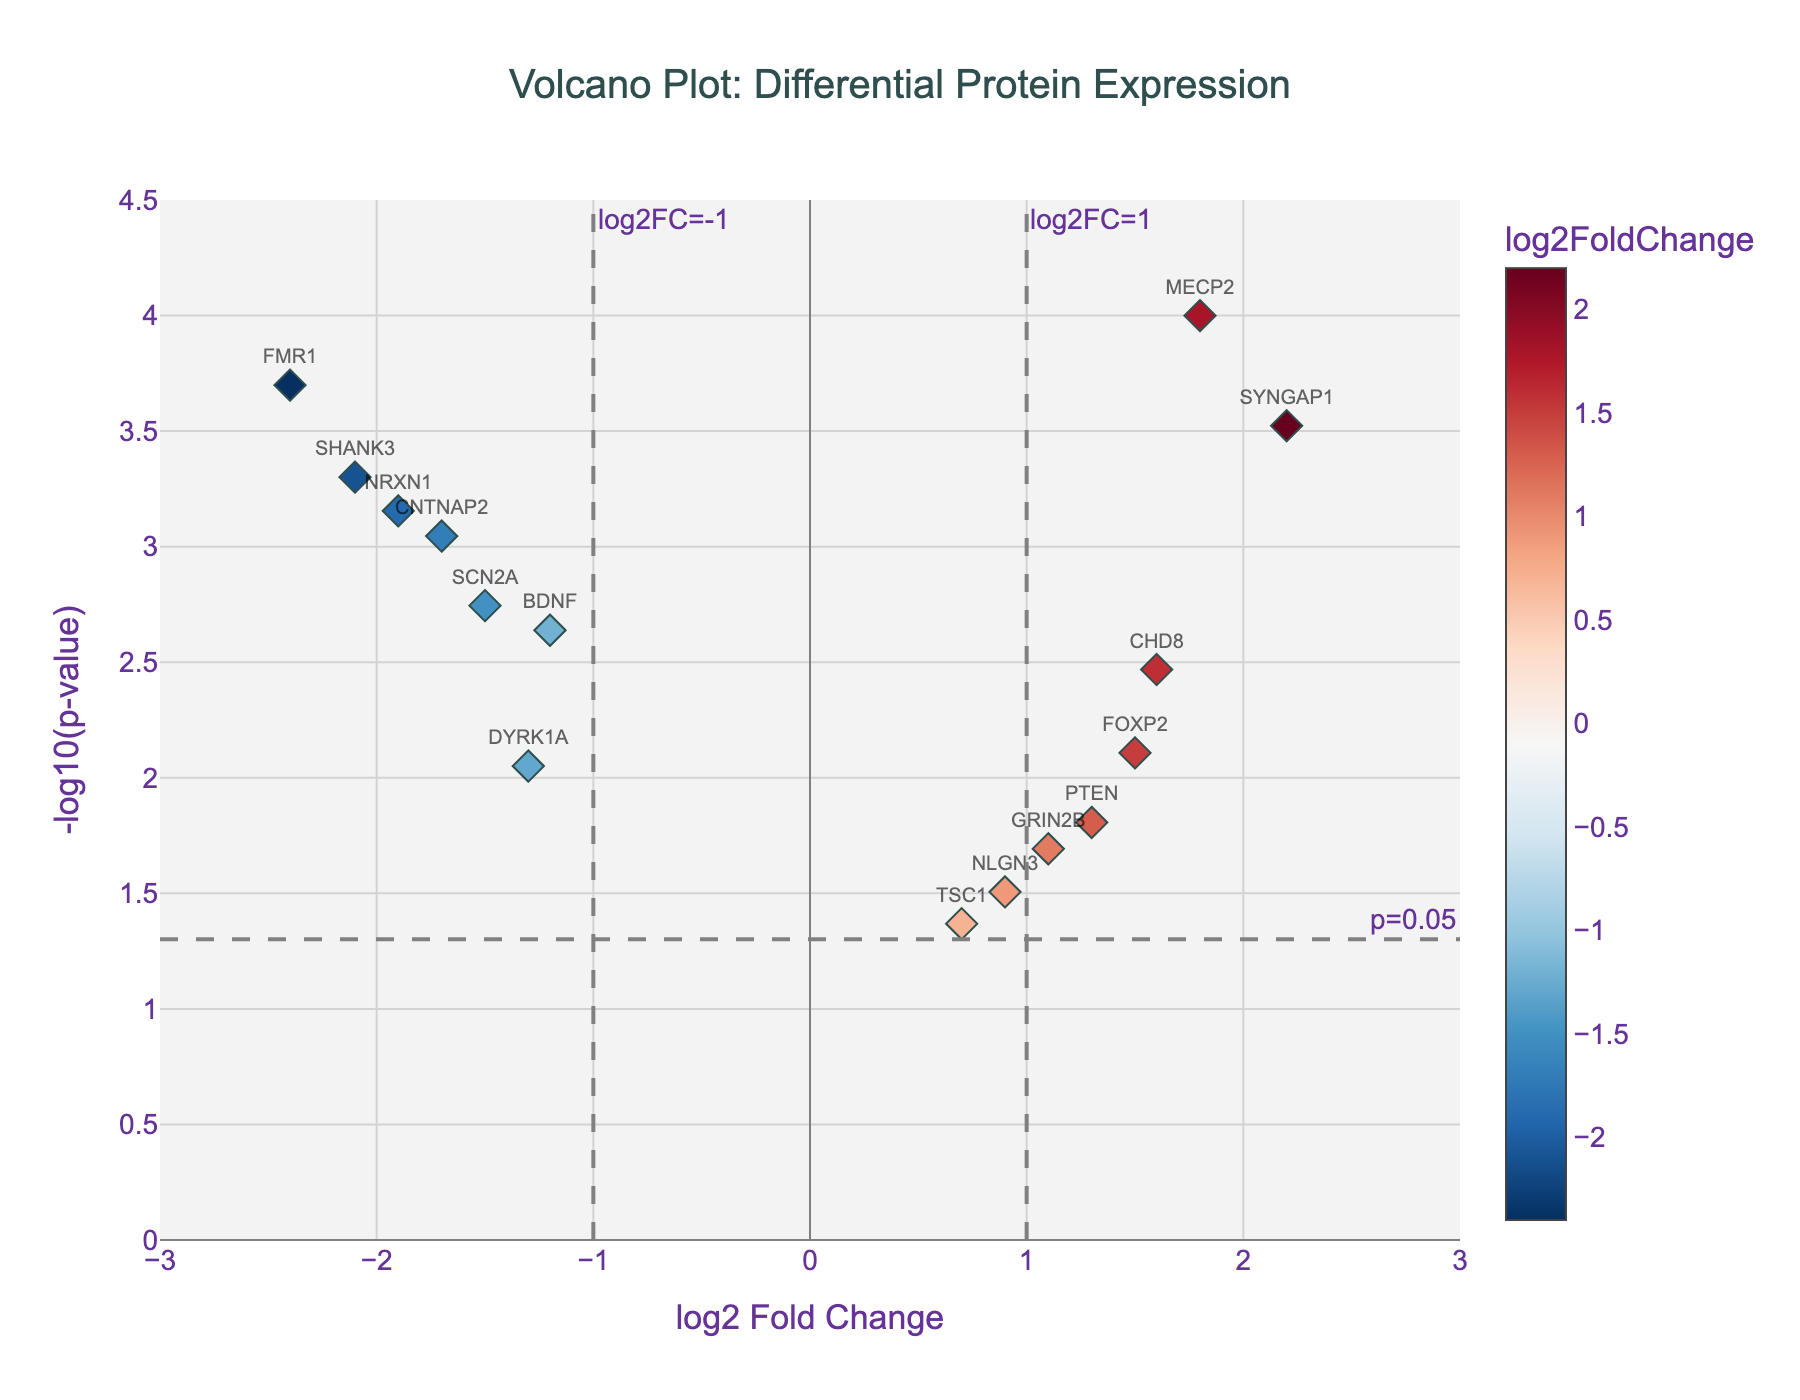What is the title of the figure? The title is located at the top center of the plot. It typically provides a brief and clear description of what the plot is about. In this case, it reads "Volcano Plot: Differential Protein Expression".
Answer: Volcano Plot: Differential Protein Expression How many proteins are shown in the plot? Each point on the plot represents a protein, and each protein has its name displayed above the corresponding point. By counting the names displayed, you can determine the total number of proteins.
Answer: 15 Which protein has the highest -log10(p-value)? To determine this, identify the point that is highest on the y-axis. The corresponding protein label above that point is the protein with the highest -log10(p-value).
Answer: SYNGAP1 Are there any proteins with a positive log2 fold change and a -log10(p-value) above 2? If so, which ones? Look at the points on the right side of the x-axis (positive log2 fold change) and check if any of them are above the y-axis value of 2. The proteins corresponding to these points are the answers.
Answer: MECP2, FOXP2, PTEN, GRIN2B, CHD8, SYNGAP1 Which proteins have a log2 fold change less than -1 and a p-value less than 0.005? First, identify points on the left side of the plot (log2 fold change < -1). Then check the -log10(p-value) of these points, ensuring it is greater than -log10(0.005), which is 2.3010. These proteins will be the answer.
Answer: BDNF, SHANK3, CNTNAP2, FMR1, NRXN1, SCN2A How many proteins have a -log10(p-value) greater than 1.5? Identify points on the plot that are above the horizontal line corresponding to the -log10(p-value) of 1.5. Count these points to get the answer.
Answer: 13 Between BDNF and NLGN3, which protein has a higher p-value? A higher p-value corresponds to a lower -log10(p-value). Check the positions of BDNF and NLGN3 on the y-axis; the one with the lower value will have the higher p-value.
Answer: NLGN3 Which proteins have log2 fold changes between -0.5 and 0.5, inclusive? Look for points that fall within the range -0.5 to 0.5 on the x-axis. Identify the corresponding protein names above these points.
Answer: No proteins fall within this range What does the horizontal dashed line at y = -log10(0.05) represent? The horizontal dashed line represents the threshold for statistical significance at a p-value of 0.05. Proteins above this line are considered statistically significant.
Answer: p=0.05 threshold Which proteins are located in the upper right and upper left quadrants of the plot? The upper right quadrant contains points with positive log2 fold changes and high -log10(p-values), while the upper left quadrant contains points with negative log2 fold changes and high -log10(p-values). Identify the corresponding protein names in these regions.
Answer: Upper Right: MECP2, FOXP2, PTEN, SYNGAP1, CHD8; Upper Left: BDNF, SHANK3, CNTNAP2, FMR1, NRXN1 